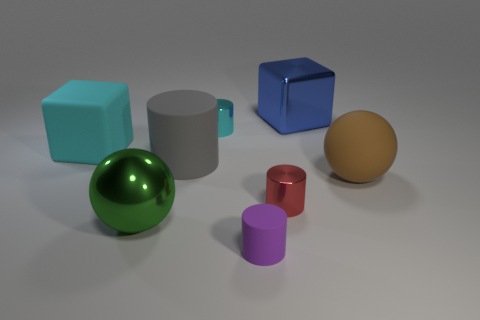Is there a small metallic cylinder that has the same color as the matte block?
Your response must be concise. Yes. Is the shape of the big rubber object to the right of the tiny purple thing the same as the large metal object in front of the cyan cylinder?
Keep it short and to the point. Yes. Are there any cylinders made of the same material as the brown object?
Ensure brevity in your answer.  Yes. How many brown objects are large metal cylinders or metal things?
Offer a terse response. 0. There is a rubber object that is both left of the big blue block and to the right of the gray rubber thing; what is its size?
Offer a terse response. Small. Are there more cyan things on the right side of the large gray matte object than tiny blue metal objects?
Your answer should be compact. Yes. What number of spheres are big blue objects or big rubber objects?
Offer a terse response. 1. The matte object that is to the right of the large gray object and behind the green metal object has what shape?
Give a very brief answer. Sphere. Is the number of metallic balls that are on the right side of the red metallic cylinder the same as the number of objects on the left side of the small cyan shiny object?
Provide a short and direct response. No. How many objects are either large gray matte things or big green metal things?
Provide a short and direct response. 2. 